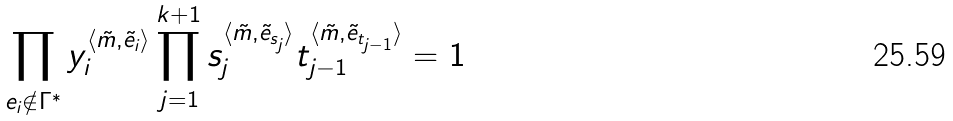Convert formula to latex. <formula><loc_0><loc_0><loc_500><loc_500>\prod _ { e _ { i } \notin \Gamma ^ { * } } y _ { i } ^ { \langle \tilde { m } , \tilde { e } _ { i } \rangle } \prod _ { j = 1 } ^ { k + 1 } s _ { j } ^ { \langle \tilde { m } , \tilde { e } _ { s _ { j } } \rangle } t _ { j - 1 } ^ { \langle \tilde { m } , \tilde { e } _ { t _ { j - 1 } } \rangle } = 1</formula> 